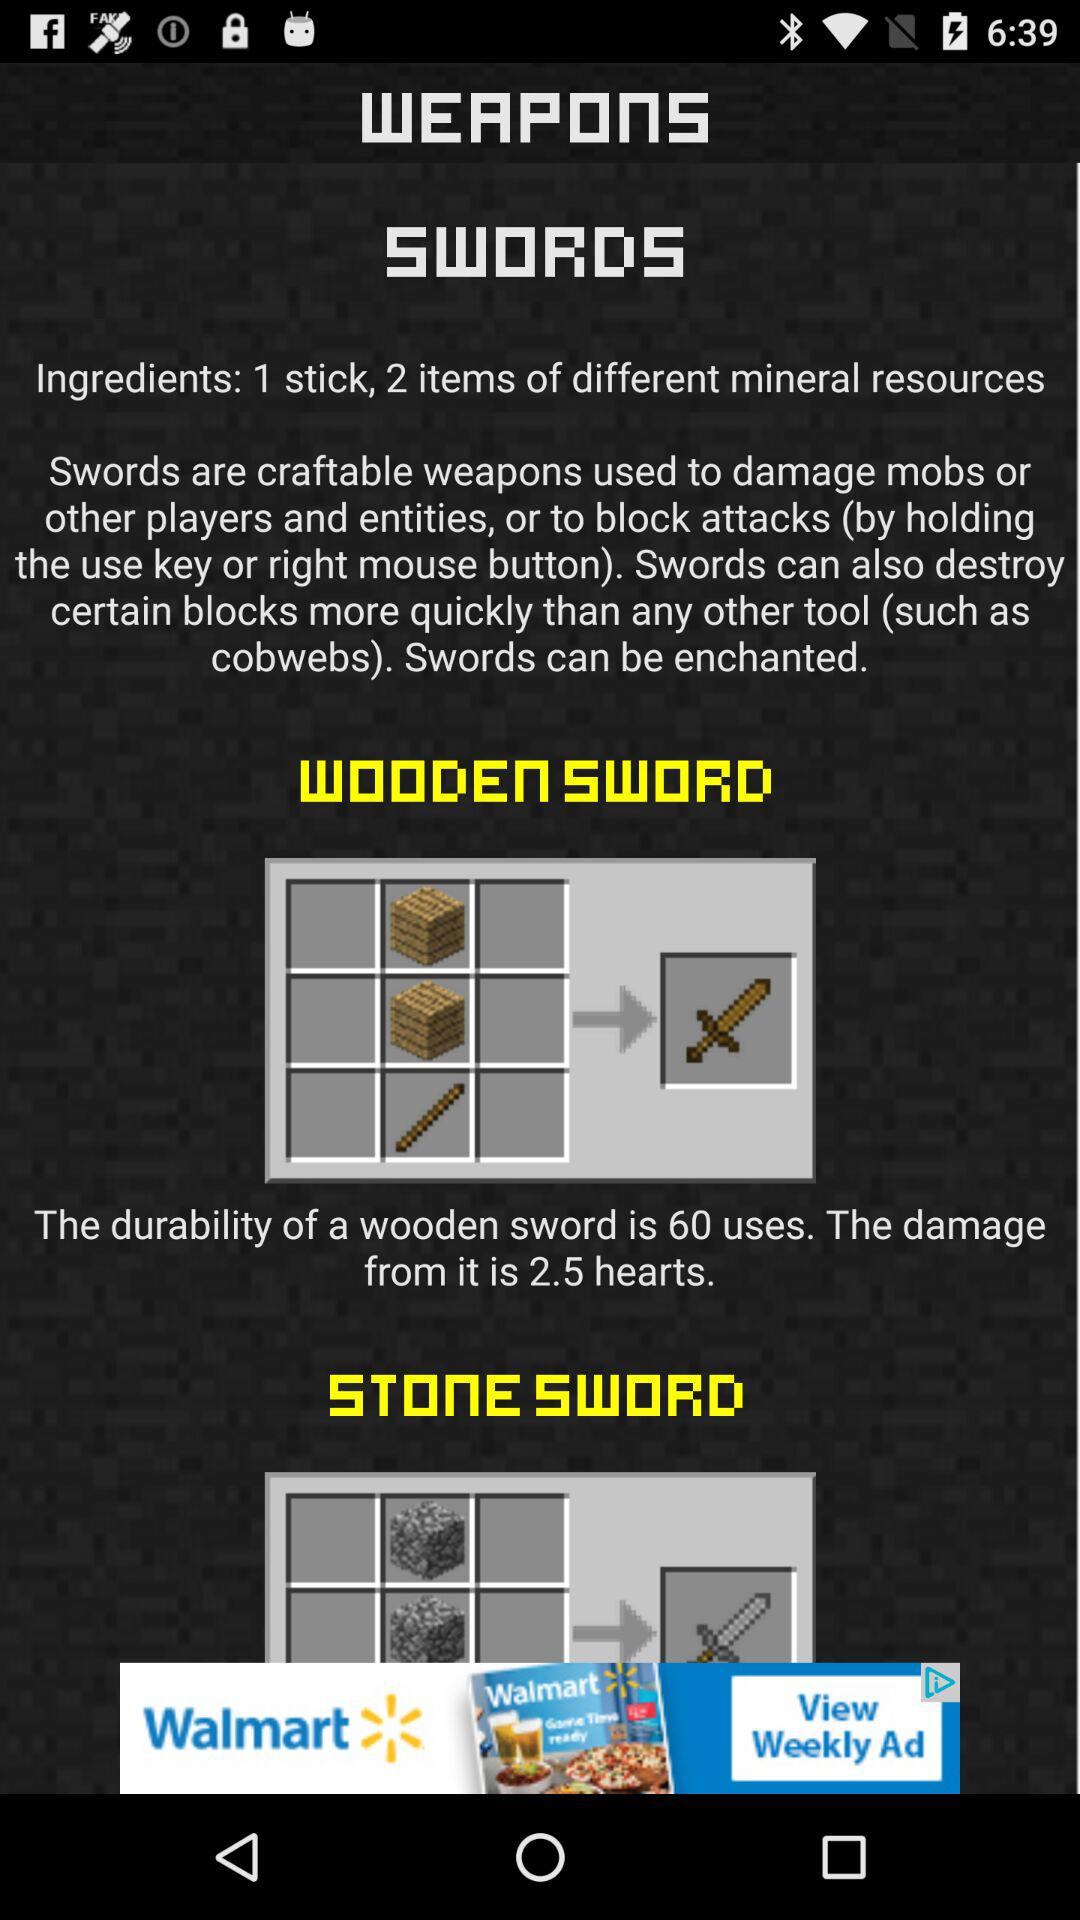What are the ingredients for "SWORDS"? The ingredients are 1 stick and 2 items of different mineral resources. 